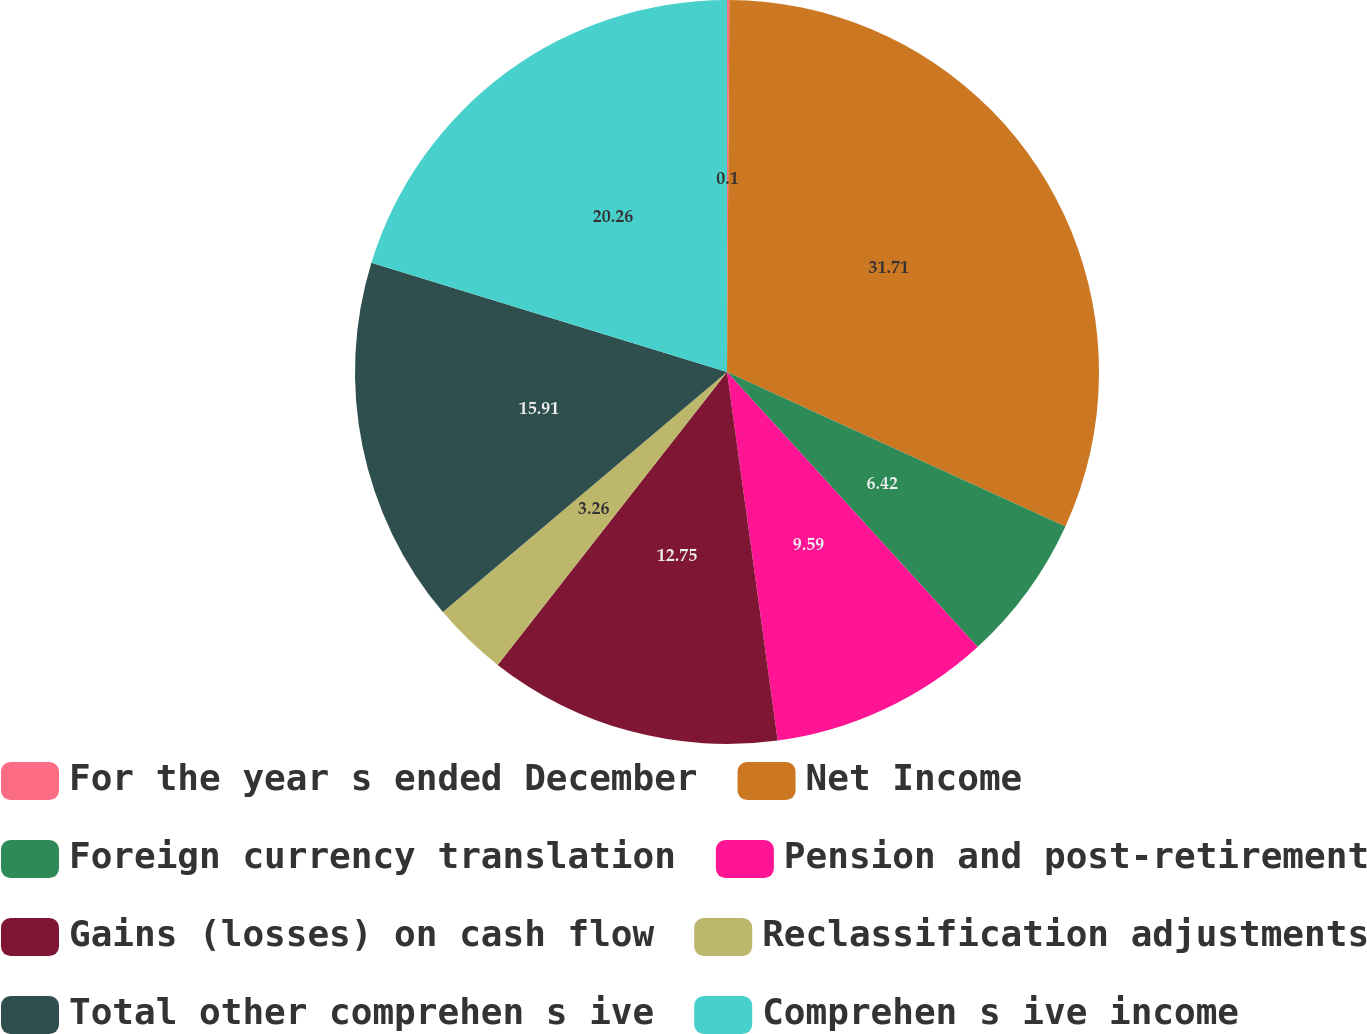Convert chart. <chart><loc_0><loc_0><loc_500><loc_500><pie_chart><fcel>For the year s ended December<fcel>Net Income<fcel>Foreign currency translation<fcel>Pension and post-retirement<fcel>Gains (losses) on cash flow<fcel>Reclassification adjustments<fcel>Total other comprehen s ive<fcel>Comprehen s ive income<nl><fcel>0.1%<fcel>31.72%<fcel>6.42%<fcel>9.59%<fcel>12.75%<fcel>3.26%<fcel>15.91%<fcel>20.26%<nl></chart> 